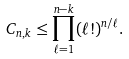<formula> <loc_0><loc_0><loc_500><loc_500>C _ { n , k } \leq \prod _ { \ell = 1 } ^ { n - k } ( \ell ! ) ^ { n / \ell } .</formula> 